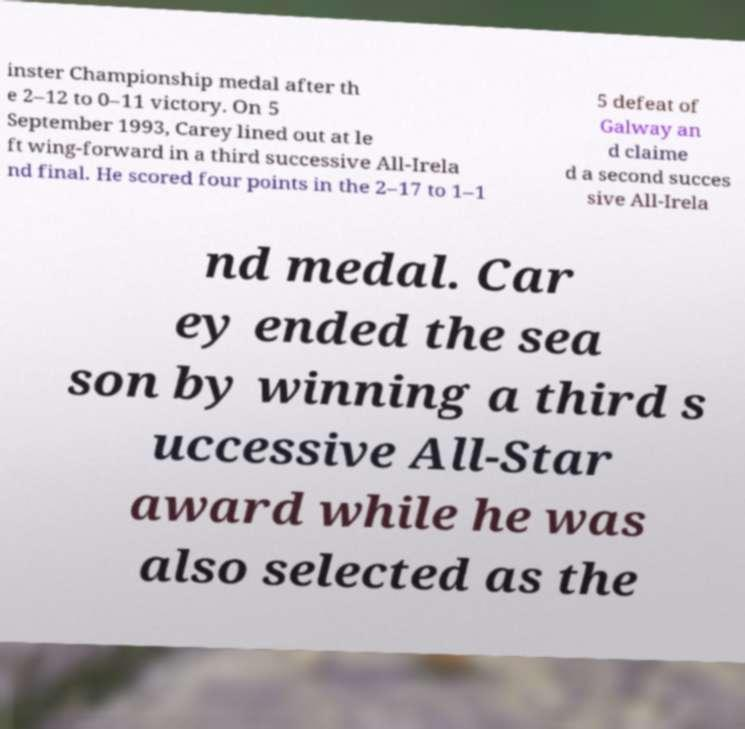Can you accurately transcribe the text from the provided image for me? inster Championship medal after th e 2–12 to 0–11 victory. On 5 September 1993, Carey lined out at le ft wing-forward in a third successive All-Irela nd final. He scored four points in the 2–17 to 1–1 5 defeat of Galway an d claime d a second succes sive All-Irela nd medal. Car ey ended the sea son by winning a third s uccessive All-Star award while he was also selected as the 